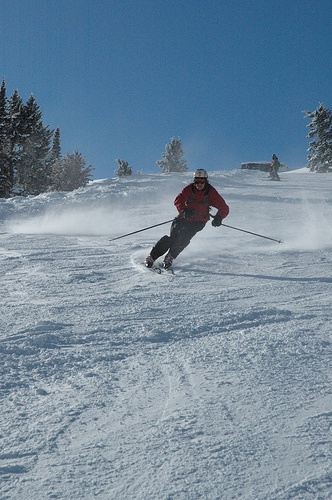Describe the objects in this image and their specific colors. I can see people in gray, black, and maroon tones, skis in gray, darkgray, black, and darkblue tones, and people in gray, purple, and black tones in this image. 